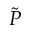<formula> <loc_0><loc_0><loc_500><loc_500>\tilde { P }</formula> 